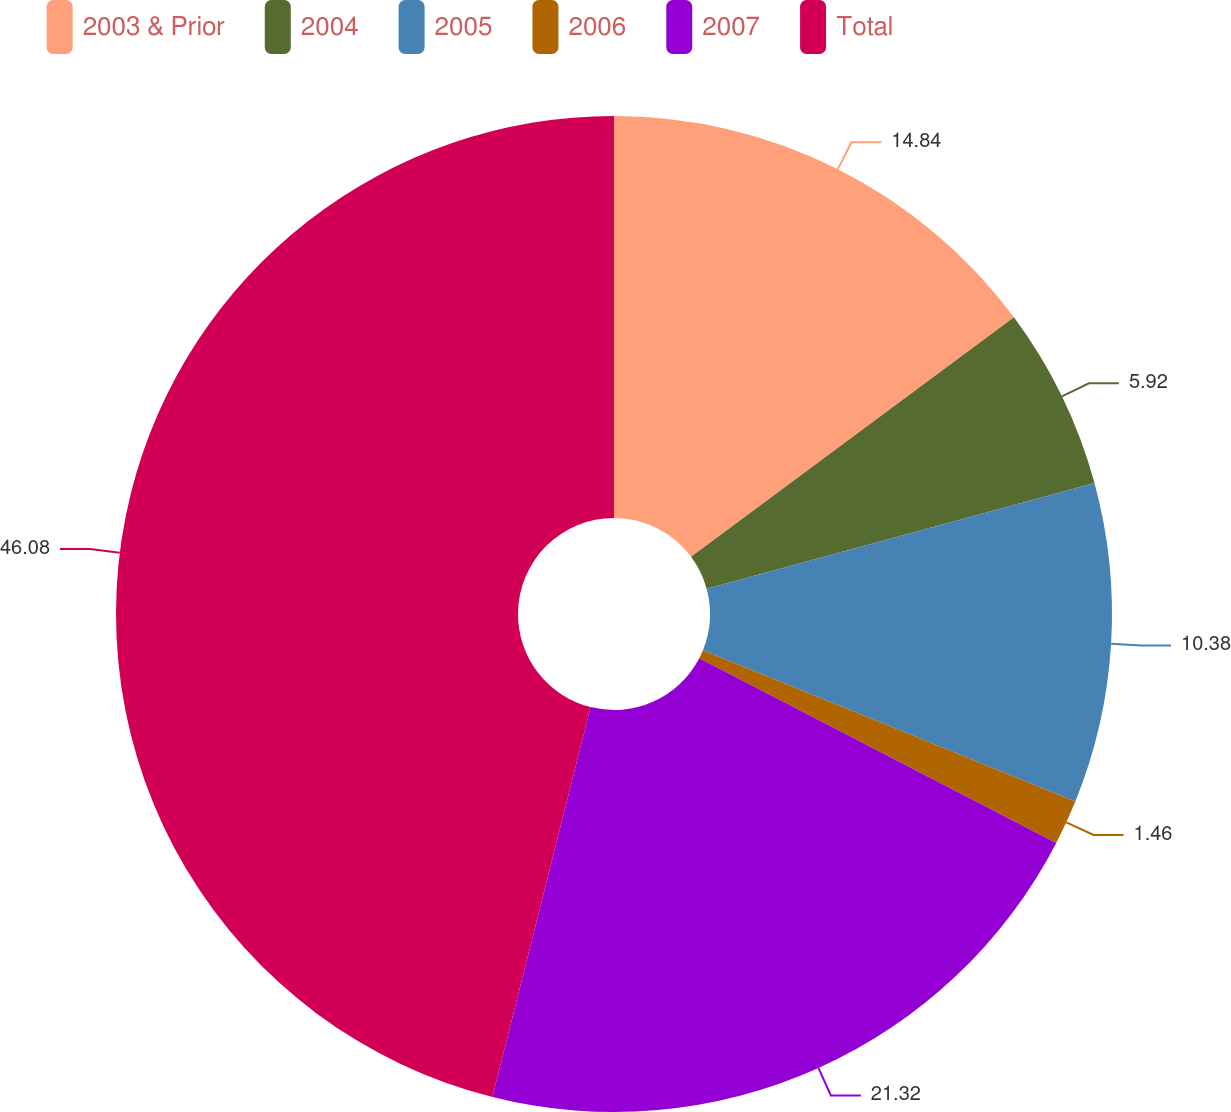Convert chart to OTSL. <chart><loc_0><loc_0><loc_500><loc_500><pie_chart><fcel>2003 & Prior<fcel>2004<fcel>2005<fcel>2006<fcel>2007<fcel>Total<nl><fcel>14.84%<fcel>5.92%<fcel>10.38%<fcel>1.46%<fcel>21.32%<fcel>46.07%<nl></chart> 